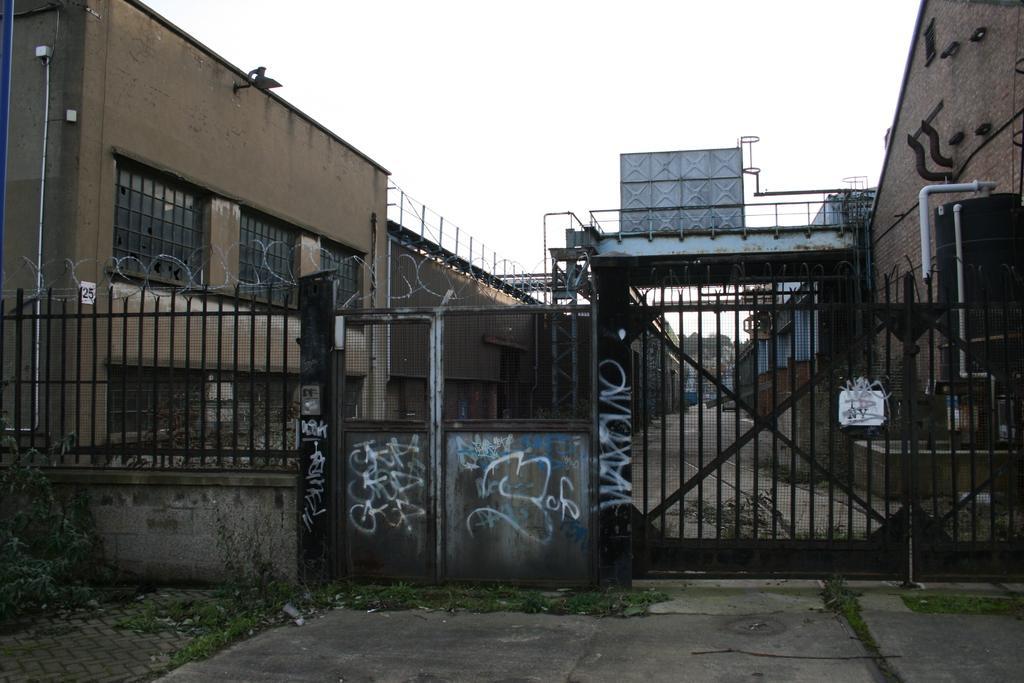Describe this image in one or two sentences. In this image we can see wall, fence, gate, plants, buildings, and few objects. In the background there is sky. 